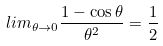<formula> <loc_0><loc_0><loc_500><loc_500>l i m _ { \theta \rightarrow 0 } \frac { 1 - \cos \theta } { \theta ^ { 2 } } = \frac { 1 } { 2 }</formula> 